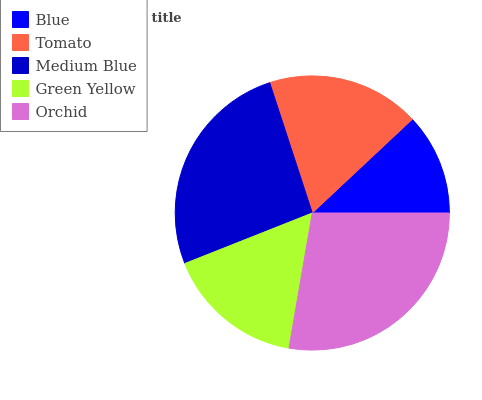Is Blue the minimum?
Answer yes or no. Yes. Is Orchid the maximum?
Answer yes or no. Yes. Is Tomato the minimum?
Answer yes or no. No. Is Tomato the maximum?
Answer yes or no. No. Is Tomato greater than Blue?
Answer yes or no. Yes. Is Blue less than Tomato?
Answer yes or no. Yes. Is Blue greater than Tomato?
Answer yes or no. No. Is Tomato less than Blue?
Answer yes or no. No. Is Tomato the high median?
Answer yes or no. Yes. Is Tomato the low median?
Answer yes or no. Yes. Is Blue the high median?
Answer yes or no. No. Is Green Yellow the low median?
Answer yes or no. No. 